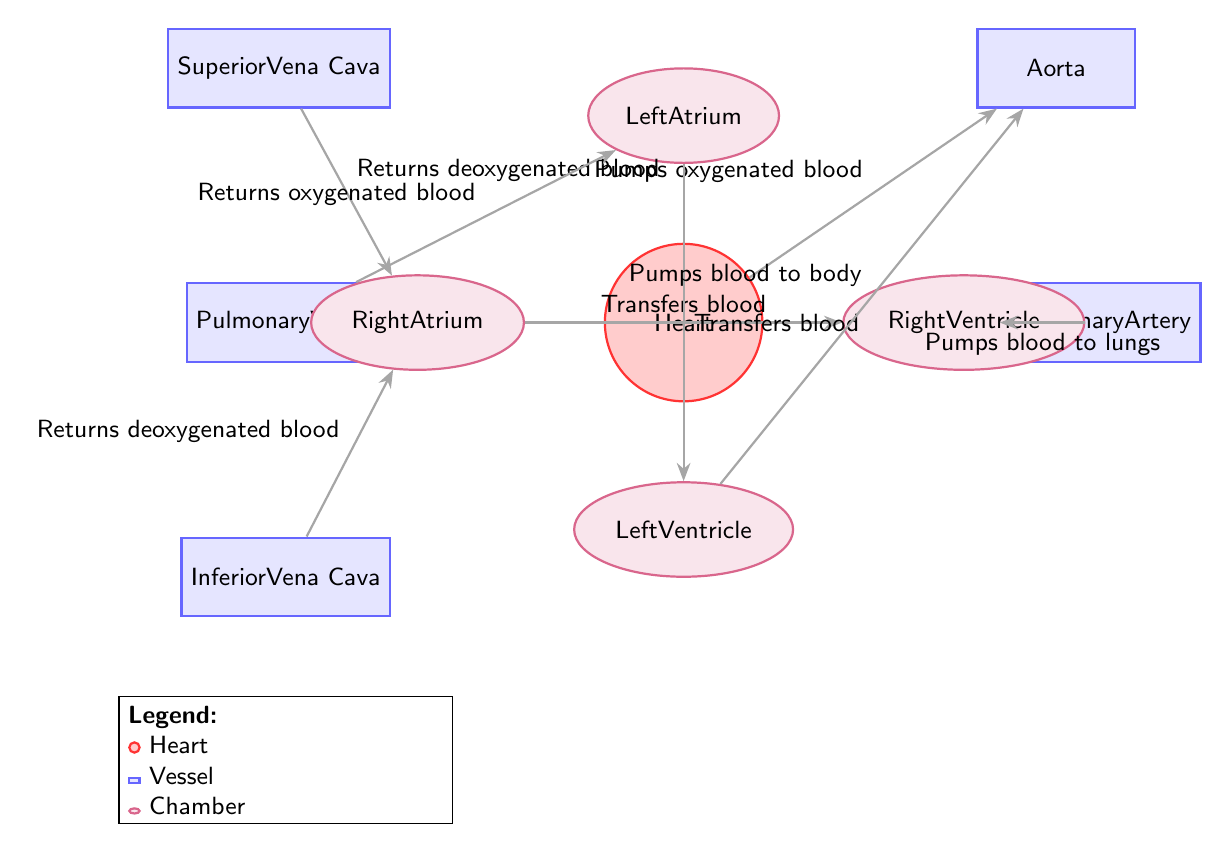What is the name of the chamber at the bottom left of the heart? The chamber located at the bottom left of the heart is labeled as the Left Ventricle in the diagram.
Answer: Left Ventricle How many vessels are shown in the diagram? The diagram includes five vessels: Aorta, Superior Vena Cava, Inferior Vena Cava, Pulmonary Artery, and Pulmonary Vein.
Answer: 5 What type of blood does the Aorta carry? The flow from the heart to the Aorta is labeled "Pumps oxygenated blood," indicating that the Aorta carries oxygenated blood.
Answer: Oxygenated blood Which chamber transfers blood to the Right Ventricle? The diagram indicates that the Right Atrium transfers blood to the Right Ventricle as per the labeled flow "Transfers blood."
Answer: Right Atrium What is the function of the Pulmonary Artery? The diagram shows that the Pulmonary Artery is involved in the flow labeled "Pumps blood to lungs," meaning it carries blood to the lungs for oxygenation.
Answer: Pumps blood to lungs What path does deoxygenated blood take from the body to the heart? Deoxygenated blood returns from the body via two vessels: the Superior Vena Cava and the Inferior Vena Cava, both transferring blood to the Right Atrium.
Answer: SVC and IVC to Right Atrium Which node is directly connected to the Pulmonary Vein? The Pulmonary Vein is directly connected to the Left Atrium, as depicted by the flow labeled "Returns oxygenated blood."
Answer: Left Atrium How many chambers are part of the heart in this diagram? According to the diagram, there are four chambers: Left Atrium, Left Ventricle, Right Atrium, and Right Ventricle.
Answer: 4 